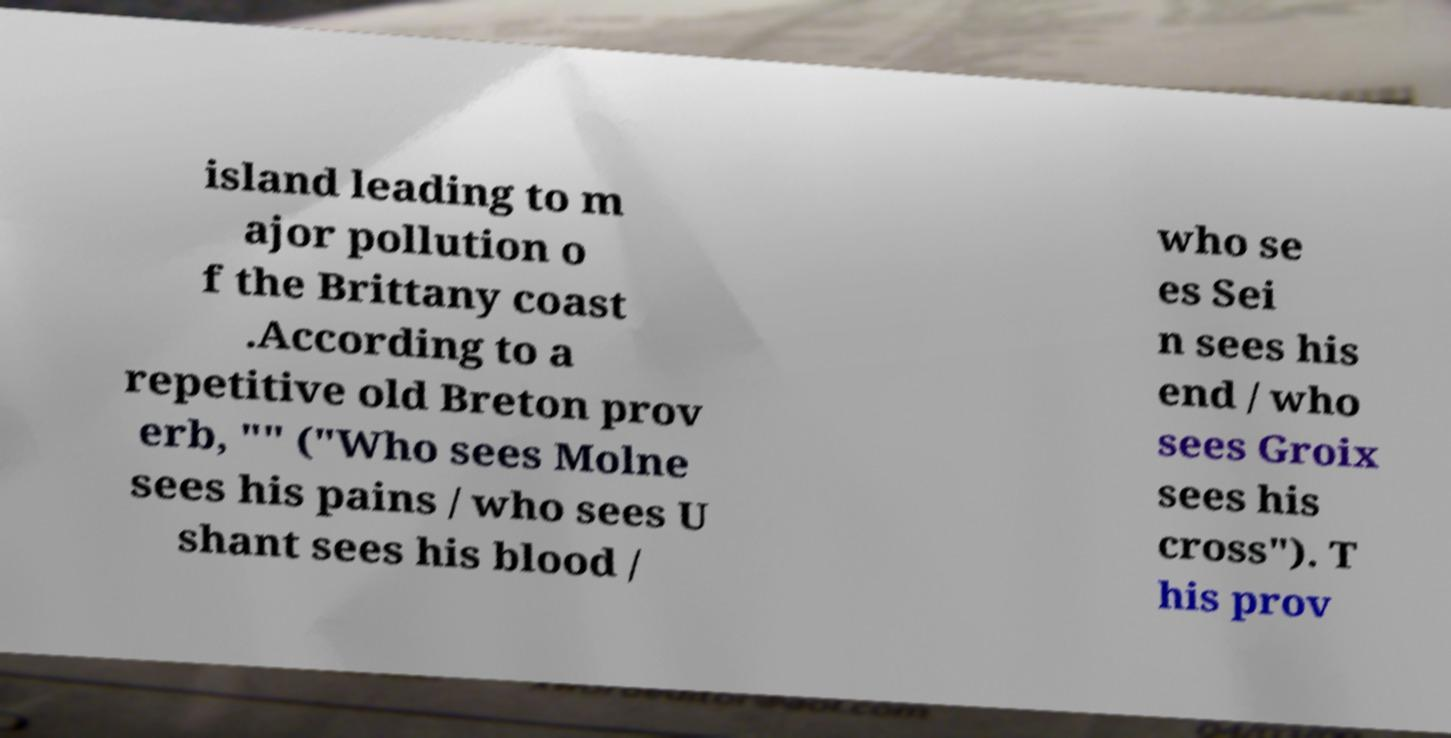Can you accurately transcribe the text from the provided image for me? island leading to m ajor pollution o f the Brittany coast .According to a repetitive old Breton prov erb, "" ("Who sees Molne sees his pains / who sees U shant sees his blood / who se es Sei n sees his end / who sees Groix sees his cross"). T his prov 